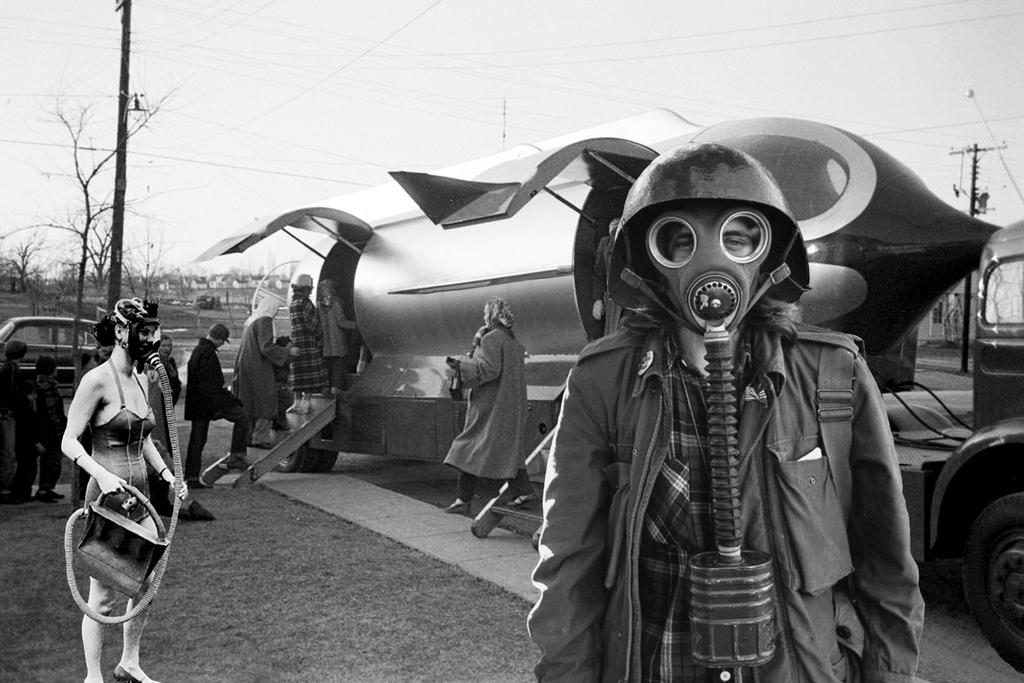How many people are present in the image? There are people in the image, but the exact number is not specified. What are some people wearing in the image? Some people are wearing masks in the image. What type of transportation can be seen in the image? There are vehicles in the image. What are the current poles and wires used for in the image? The current poles and wires are likely used for providing electricity to the area. What is the color scheme of the image? The image is in black and white. How does the mist affect the visibility of the vehicles in the image? There is no mist present in the image, so it does not affect the visibility of the vehicles. 